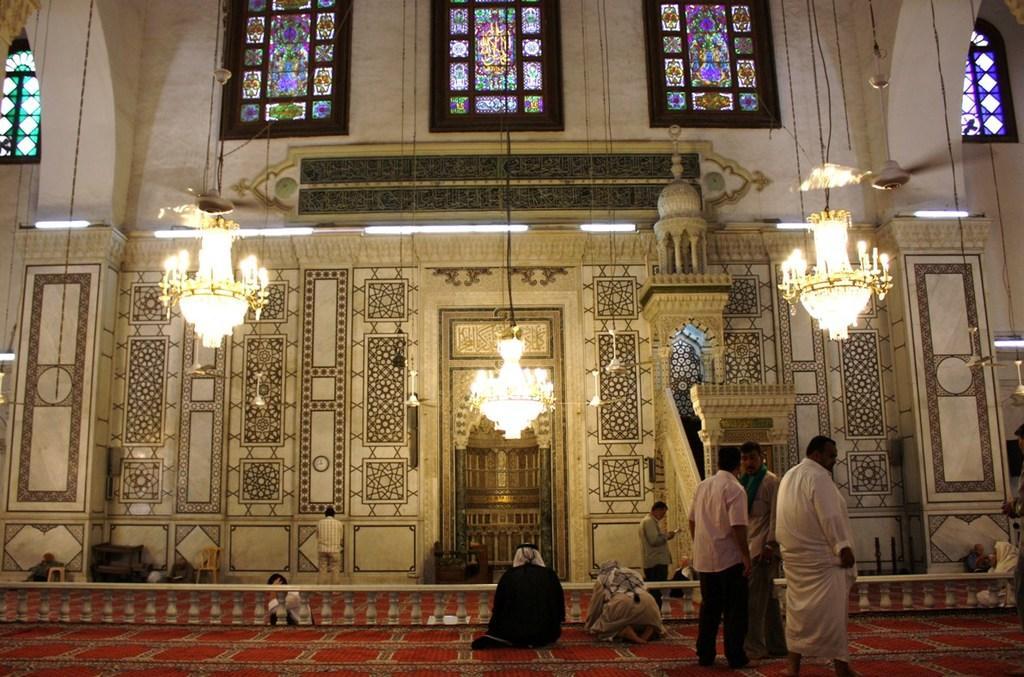Please provide a concise description of this image. In this picture we can see the inside view of a building. There are groups of people on the carpet. In front of the people, there are lights, baluster, wall and some objects. There are chandeliers and fans hanging. At the top of the image, there are stained glass windows. 